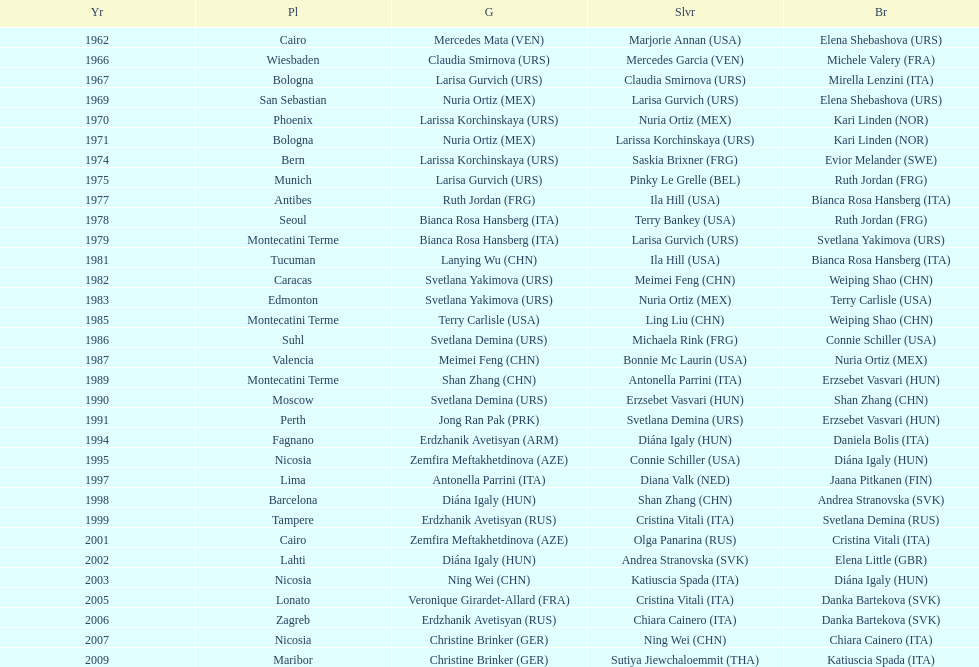What is the total of silver for cairo 0. 